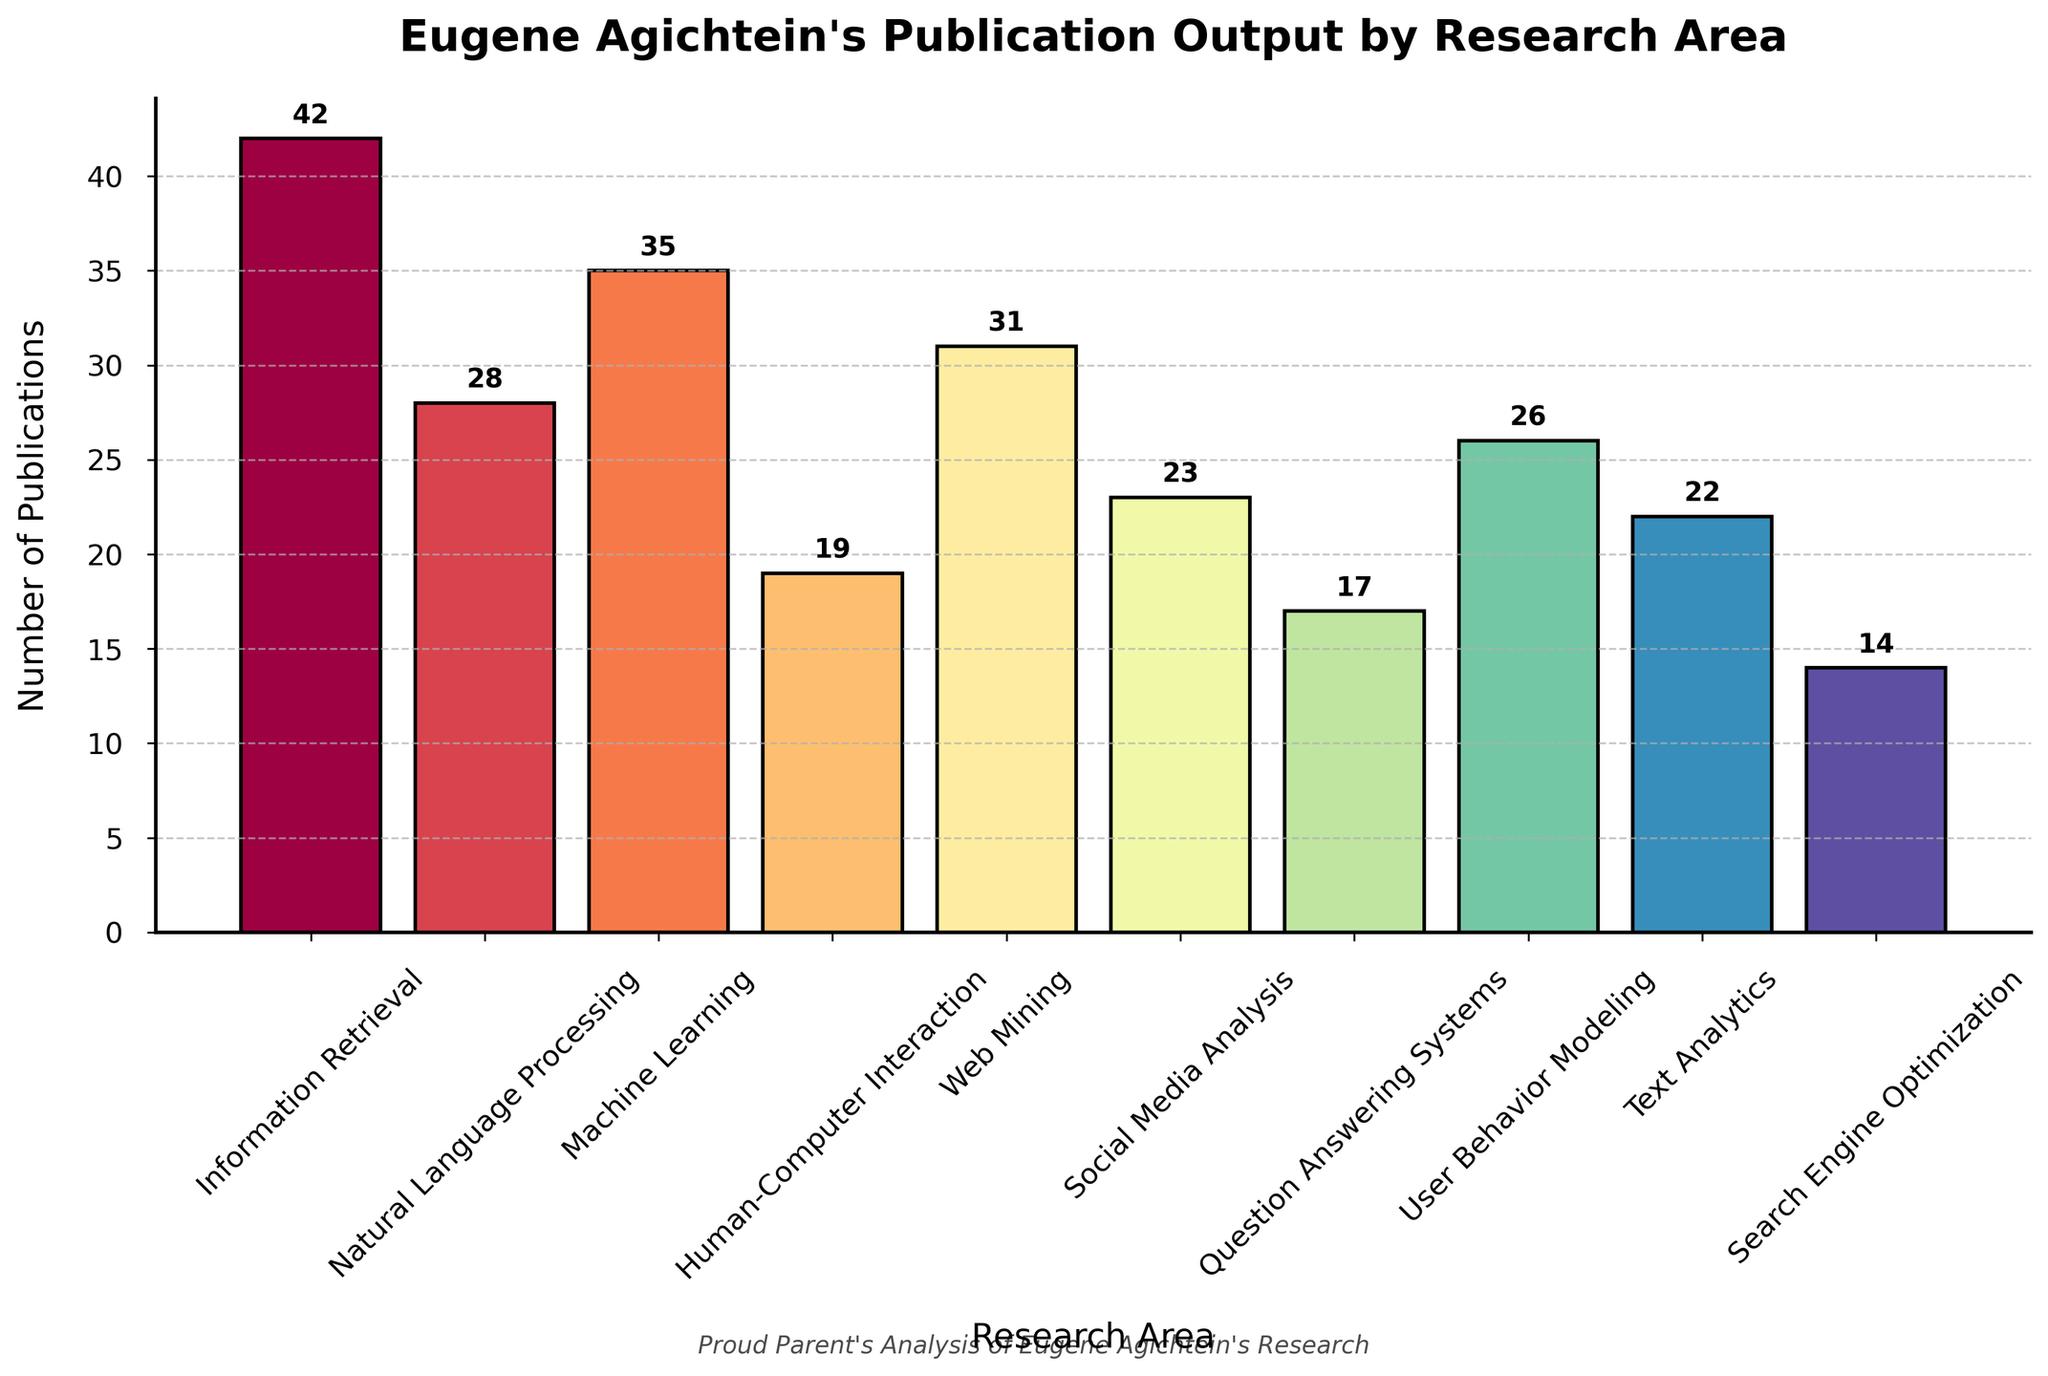Which research area did Eugene Agichtein publish the most in? The tallest bar represents the research area with the most publications. Information Retrieval has the highest bar.
Answer: Information Retrieval Which research area has the least number of publications? The shortest bar represents the research area with the least publications. Search Engine Optimization has the shortest bar.
Answer: Search Engine Optimization How many more publications are in Information Retrieval compared to Search Engine Optimization? Subtract the number of publications in Search Engine Optimization (14) from the number of publications in Information Retrieval (42). 42 - 14 = 28
Answer: 28 What is the total number of publications in Human-Computer Interaction, Social Media Analysis, and Text Analytics combined? Add the number of publications in these three areas: 19 (HCI) + 23 (Social Media Analysis) + 22 (Text Analytics). 19 + 23 + 22 = 64
Answer: 64 Which research area has more publications: Natural Language Processing or User Behavior Modeling? Compare the heights of the bars for Natural Language Processing (28) and User Behavior Modeling (26). Natural Language Processing has more publications.
Answer: Natural Language Processing How many publications does Eugene Agichtein have in Machine Learning and Web Mining combined? Add the number of publications in Machine Learning (35) and Web Mining (31). 35 + 31 = 66
Answer: 66 What is the average number of publications across all research areas? Sum the number of publications in all areas (42 + 28 + 35 + 19 + 31 + 23 + 17 + 26 + 22 + 14) and divide by the number of areas (10). (42 + 28 + 35 + 19 + 31 + 23 + 17 + 26 + 22 + 14) / 10 = 25.7
Answer: 25.7 Which areas have more than 30 publications? Identify the bars taller than the value representing 30. These areas are Information Retrieval (42), Machine Learning (35), and Web Mining (31).
Answer: Information Retrieval, Machine Learning, Web Mining 